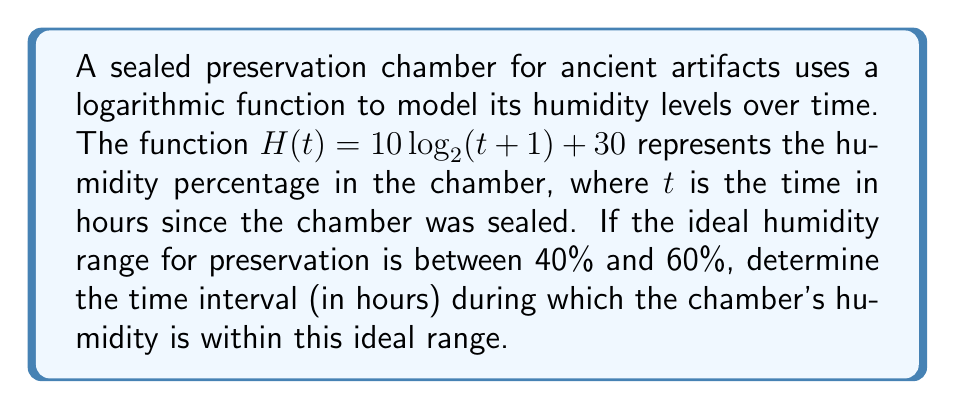Give your solution to this math problem. To solve this problem, we need to find the values of $t$ where $H(t)$ is between 40% and 60%. Let's approach this step-by-step:

1) Set up two inequalities:
   
   $40 \leq 10 \log_2(t+1) + 30 \leq 60$

2) Subtract 30 from all parts of the inequality:
   
   $10 \leq 10 \log_2(t+1) \leq 30$

3) Divide all parts by 10:
   
   $1 \leq \log_2(t+1) \leq 3$

4) Apply $2^x$ to all parts (this is valid because $2^x$ is an increasing function):
   
   $2^1 \leq 2^{\log_2(t+1)} \leq 2^3$

5) Simplify:
   
   $2 \leq t+1 \leq 8$

6) Subtract 1 from all parts:
   
   $1 \leq t \leq 7$

Therefore, the humidity is within the ideal range when $t$ is between 1 and 7 hours, inclusive.
Answer: The humidity in the chamber is within the ideal range from $t = 1$ to $t = 7$ hours, or [1, 7] hours. 